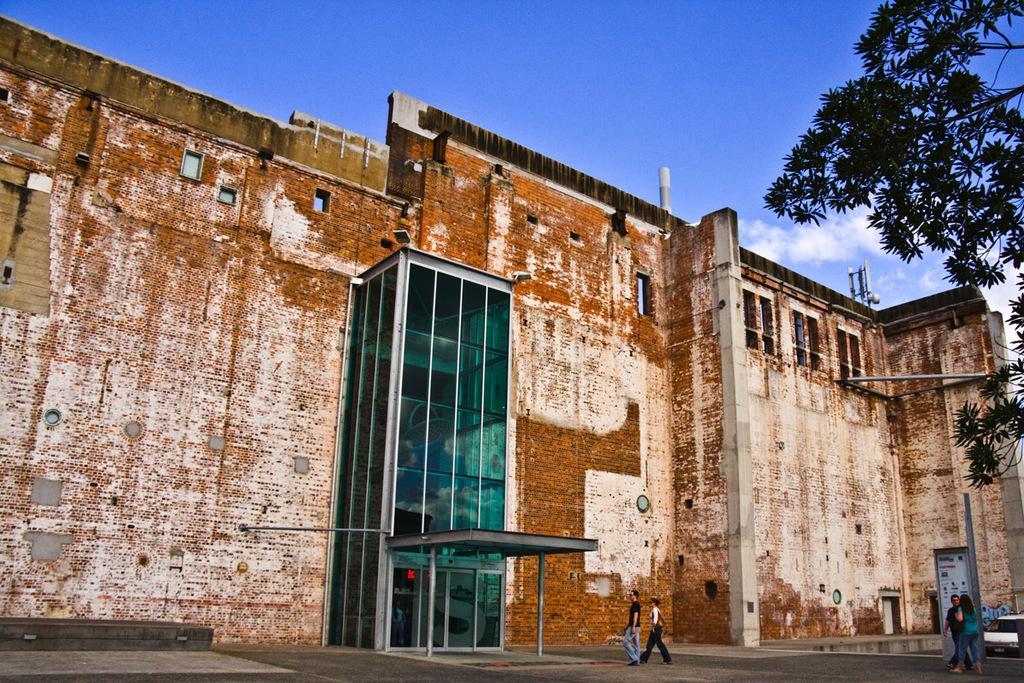How would you summarize this image in a sentence or two? In the picture I can see a building, people walking on the ground and vehicle on the ground. In the background I can see a tree, a tower, the sky and some other objects. 